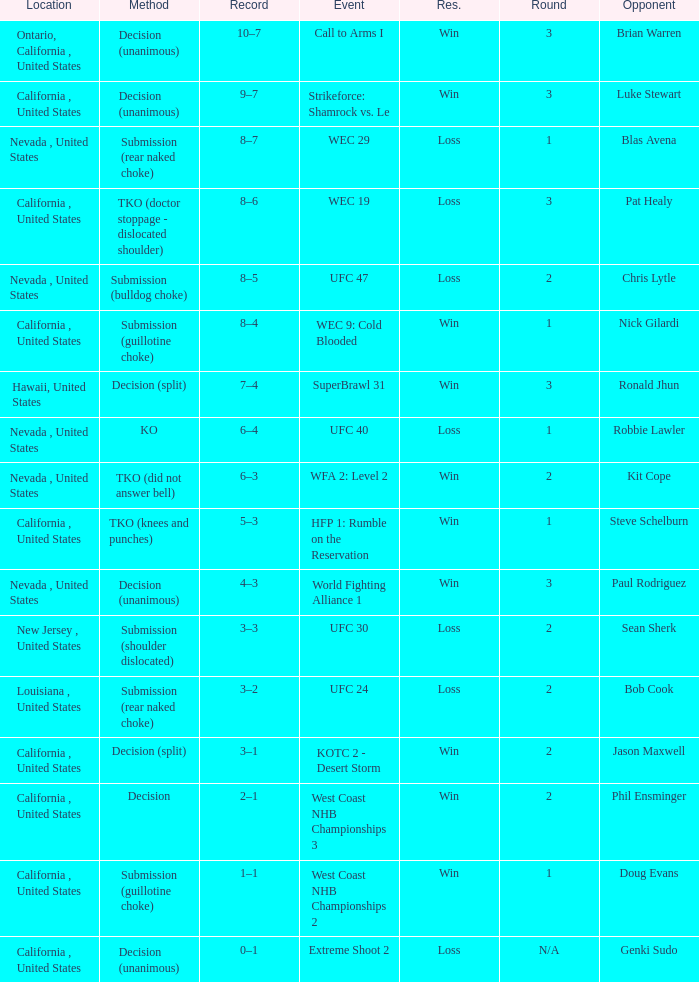What is the result for the Call to Arms I event? Win. 